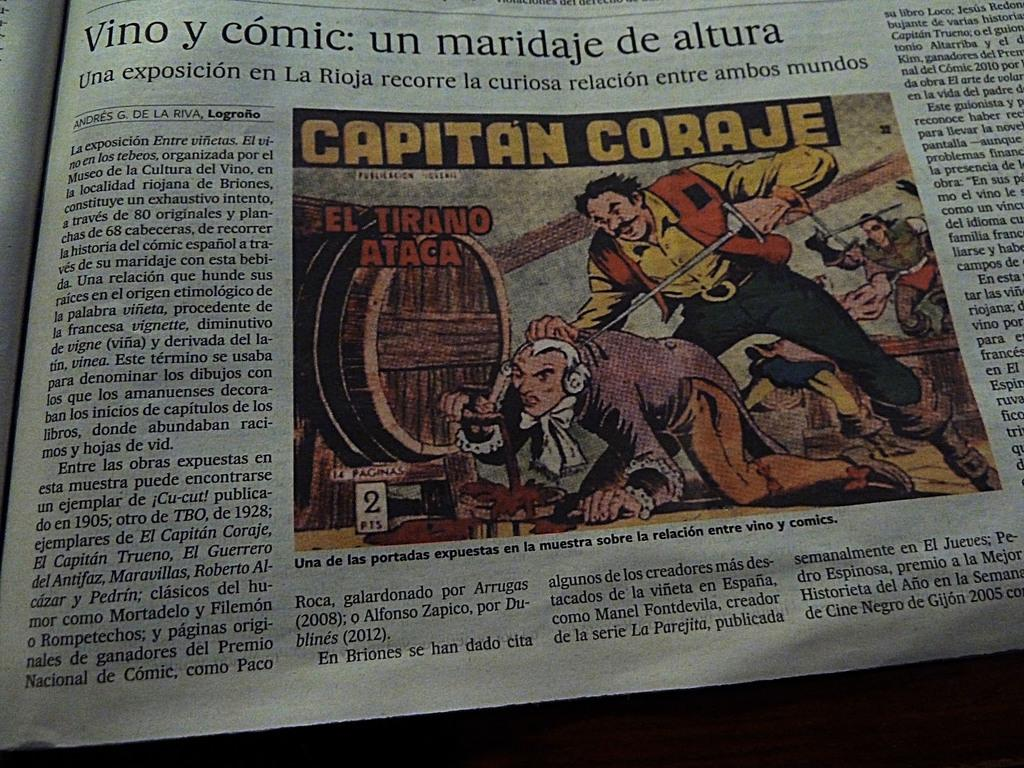What is the main subject of the image? The main subject of the image is a photo of a newspaper. Are there any other visual elements in the image besides the newspaper? Yes, there is a picture and text in the image. Can you see a deer in the image? No, there is no deer present in the image. Is there any popcorn mentioned in the text of the newspaper? We cannot determine the content of the newspaper text from the image alone, so we cannot answer whether popcorn is mentioned or not. 